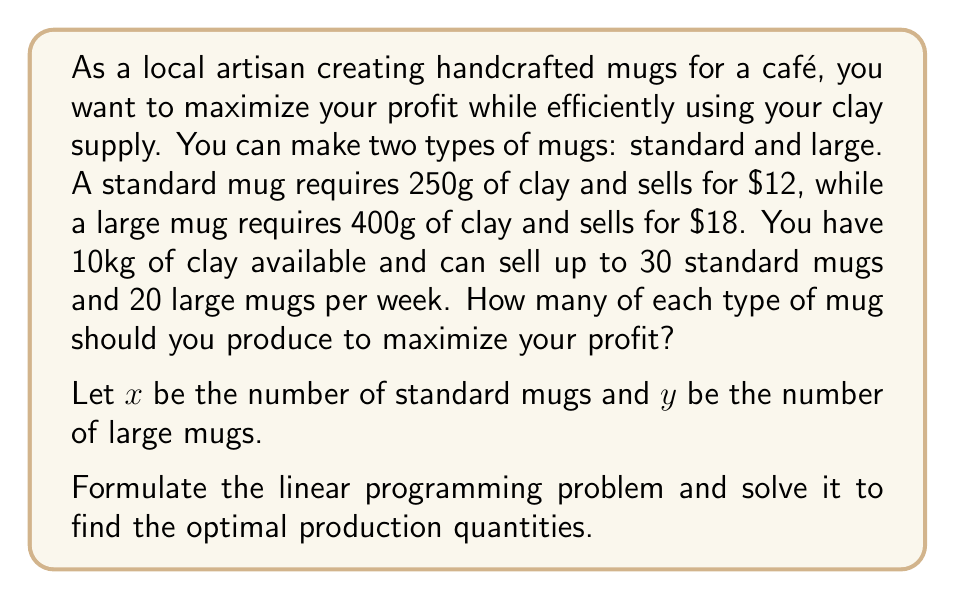Teach me how to tackle this problem. Let's approach this step-by-step:

1) First, we need to set up the objective function. We want to maximize profit:
   $$P = 12x + 18y$$

2) Now, let's identify the constraints:
   a) Clay constraint: $250x + 400y \leq 10000$ (10kg = 10000g)
   b) Standard mug demand: $x \leq 30$
   c) Large mug demand: $y \leq 20$
   d) Non-negativity: $x \geq 0, y \geq 0$

3) Our linear programming problem is now:
   Maximize $P = 12x + 18y$
   Subject to:
   $$\begin{align}
   250x + 400y &\leq 10000 \\
   x &\leq 30 \\
   y &\leq 20 \\
   x, y &\geq 0
   \end{align}$$

4) To solve this, we can use the corner point method. The feasible region is bounded by these constraints, so the optimal solution will be at one of the corner points.

5) The corner points are:
   (0, 0), (30, 0), (0, 20), (30, 10), (20, 15)

6) Let's evaluate the profit function at each point:
   P(0, 0) = 0
   P(30, 0) = 360
   P(0, 20) = 360
   P(30, 10) = 540
   P(20, 15) = 510

7) The maximum profit occurs at the point (30, 10), which means producing 30 standard mugs and 10 large mugs.
Answer: The optimal production quantities are 30 standard mugs and 10 large mugs, yielding a maximum profit of $540. 